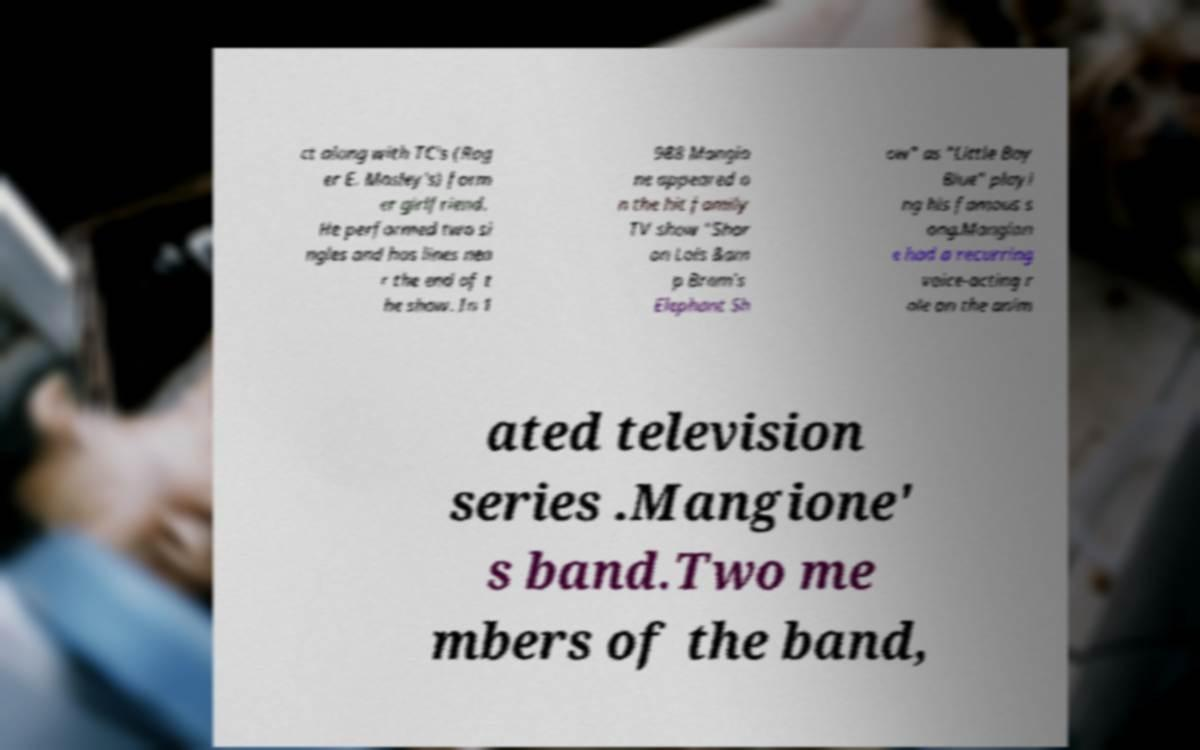Can you accurately transcribe the text from the provided image for me? ct along with TC's (Rog er E. Mosley's) form er girlfriend. He performed two si ngles and has lines nea r the end of t he show. In 1 988 Mangio ne appeared o n the hit family TV show "Shar on Lois &am p Bram's Elephant Sh ow" as "Little Boy Blue" playi ng his famous s ong.Mangion e had a recurring voice-acting r ole on the anim ated television series .Mangione' s band.Two me mbers of the band, 